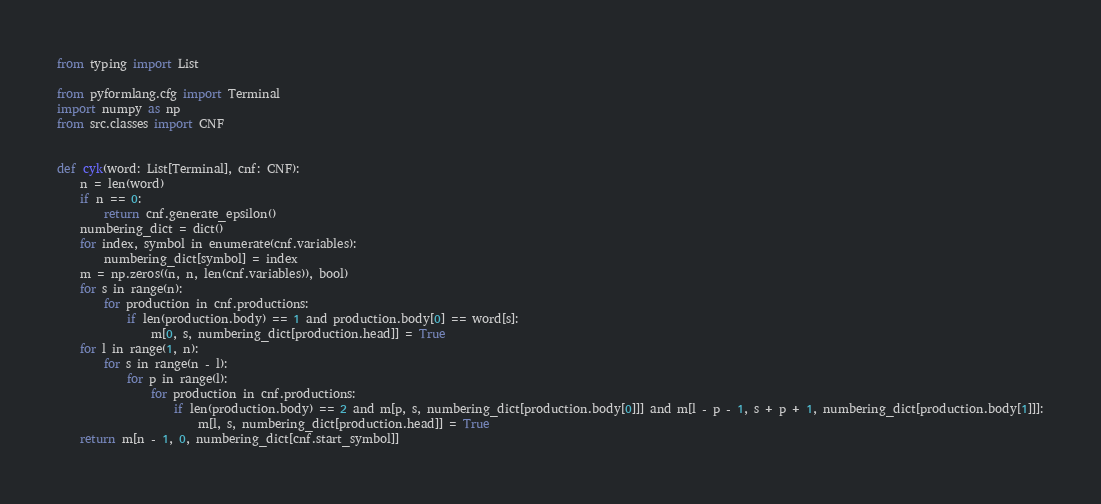Convert code to text. <code><loc_0><loc_0><loc_500><loc_500><_Python_>from typing import List

from pyformlang.cfg import Terminal
import numpy as np
from src.classes import CNF


def cyk(word: List[Terminal], cnf: CNF):
    n = len(word)
    if n == 0:
        return cnf.generate_epsilon()
    numbering_dict = dict()
    for index, symbol in enumerate(cnf.variables):
        numbering_dict[symbol] = index
    m = np.zeros((n, n, len(cnf.variables)), bool)
    for s in range(n):
        for production in cnf.productions:
            if len(production.body) == 1 and production.body[0] == word[s]:
                m[0, s, numbering_dict[production.head]] = True
    for l in range(1, n):
        for s in range(n - l):
            for p in range(l):
                for production in cnf.productions:
                    if len(production.body) == 2 and m[p, s, numbering_dict[production.body[0]]] and m[l - p - 1, s + p + 1, numbering_dict[production.body[1]]]:
                        m[l, s, numbering_dict[production.head]] = True
    return m[n - 1, 0, numbering_dict[cnf.start_symbol]]
</code> 